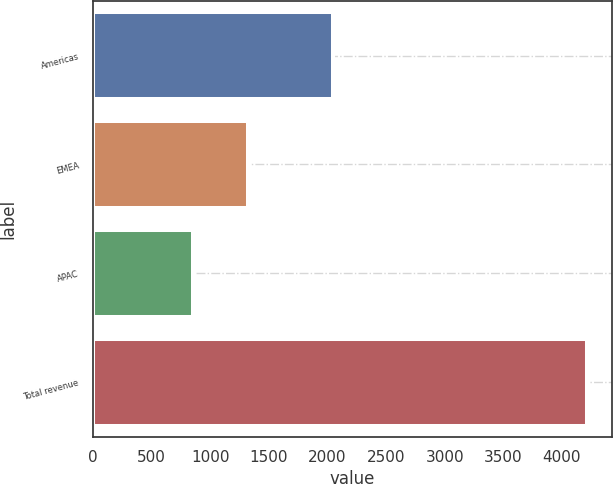<chart> <loc_0><loc_0><loc_500><loc_500><bar_chart><fcel>Americas<fcel>EMEA<fcel>APAC<fcel>Total revenue<nl><fcel>2044.6<fcel>1317.4<fcel>854.3<fcel>4216.3<nl></chart> 